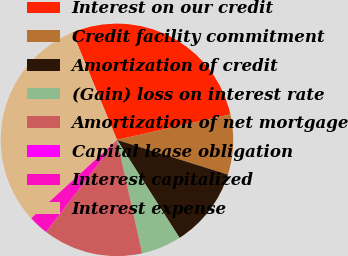<chart> <loc_0><loc_0><loc_500><loc_500><pie_chart><fcel>Interest on our credit<fcel>Credit facility commitment<fcel>Amortization of credit<fcel>(Gain) loss on interest rate<fcel>Amortization of net mortgage<fcel>Capital lease obligation<fcel>Interest capitalized<fcel>Interest expense<nl><fcel>27.73%<fcel>8.35%<fcel>11.13%<fcel>5.57%<fcel>13.91%<fcel>0.01%<fcel>2.79%<fcel>30.51%<nl></chart> 